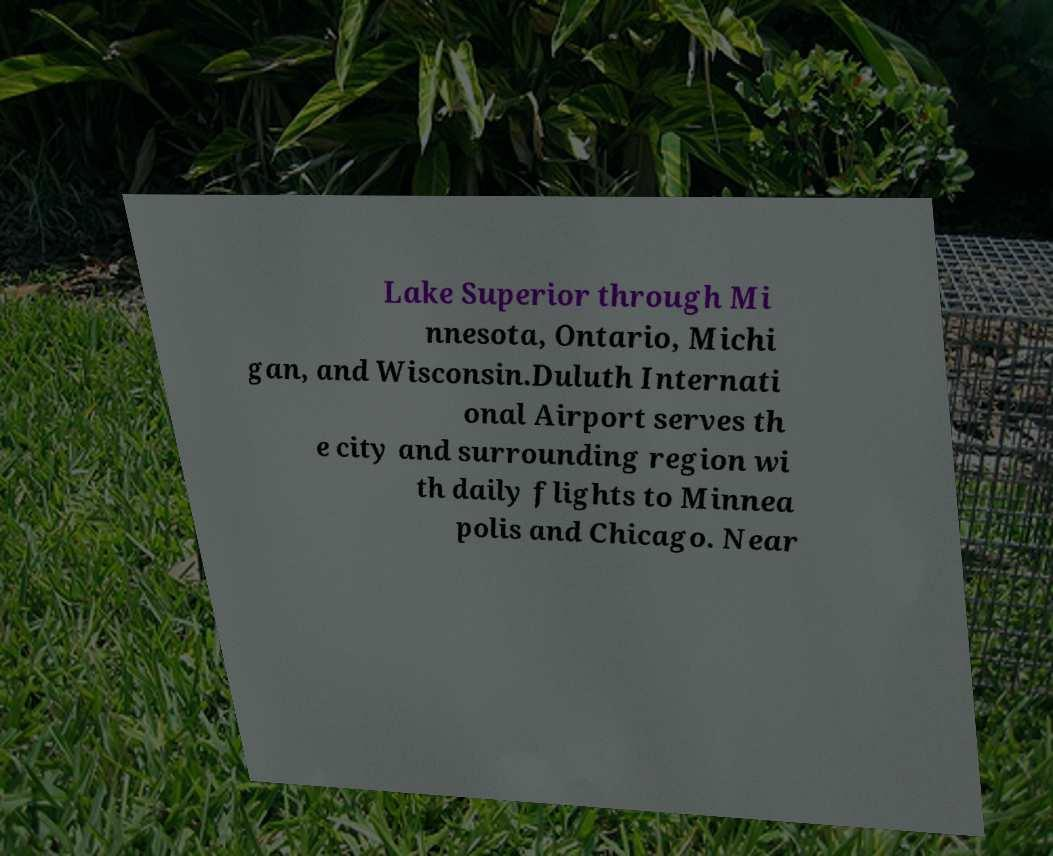Could you extract and type out the text from this image? Lake Superior through Mi nnesota, Ontario, Michi gan, and Wisconsin.Duluth Internati onal Airport serves th e city and surrounding region wi th daily flights to Minnea polis and Chicago. Near 